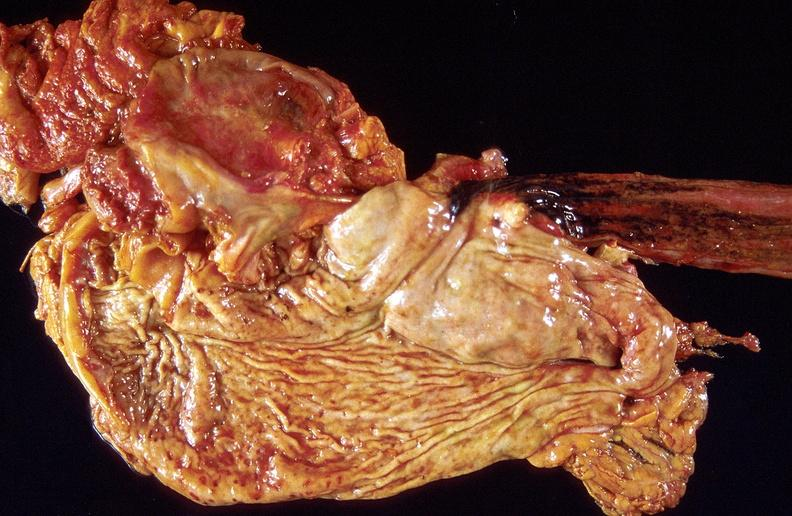s intrauterine contraceptive device present?
Answer the question using a single word or phrase. No 